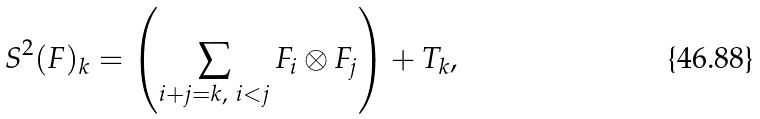<formula> <loc_0><loc_0><loc_500><loc_500>S ^ { 2 } ( F ) _ { k } = \left ( \sum _ { i + j = k , \ i < j } F _ { i } \otimes F _ { j } \right ) + T _ { k } ,</formula> 